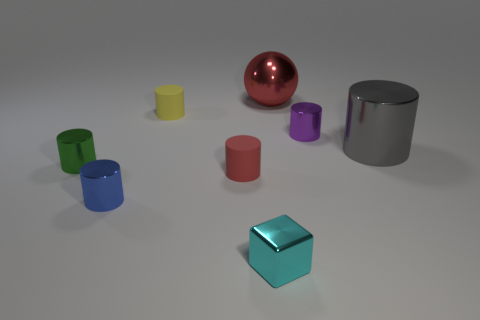How many rubber cylinders have the same color as the ball?
Keep it short and to the point. 1. There is another small rubber object that is the same shape as the yellow matte thing; what is its color?
Keep it short and to the point. Red. What is the size of the red rubber object that is the same shape as the purple thing?
Offer a very short reply. Small. What is the shape of the small thing that is the same color as the large ball?
Your answer should be very brief. Cylinder. There is a big thing that is left of the large gray cylinder; does it have the same color as the matte cylinder that is in front of the gray thing?
Provide a succinct answer. Yes. Are there more tiny purple shiny cylinders that are to the right of the red metal ball than brown cylinders?
Your answer should be compact. Yes. What is the tiny block made of?
Keep it short and to the point. Metal. What is the shape of the small cyan object that is made of the same material as the large red object?
Give a very brief answer. Cube. There is a red thing that is on the right side of the small object in front of the blue cylinder; what is its size?
Keep it short and to the point. Large. The shiny cylinder that is in front of the tiny green metal thing is what color?
Ensure brevity in your answer.  Blue. 